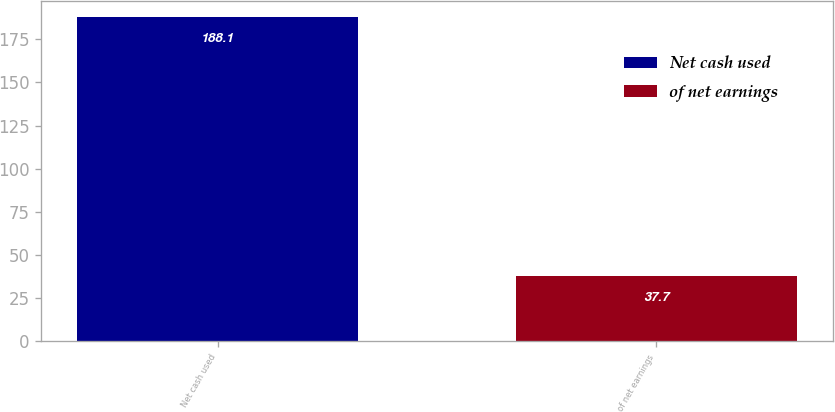Convert chart. <chart><loc_0><loc_0><loc_500><loc_500><bar_chart><fcel>Net cash used<fcel>of net earnings<nl><fcel>188.1<fcel>37.7<nl></chart> 